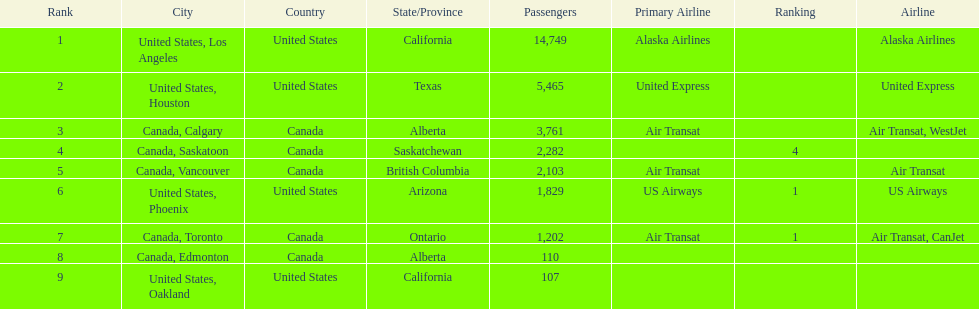Which canadian city had the most passengers traveling from manzanillo international airport in 2013? Calgary. 